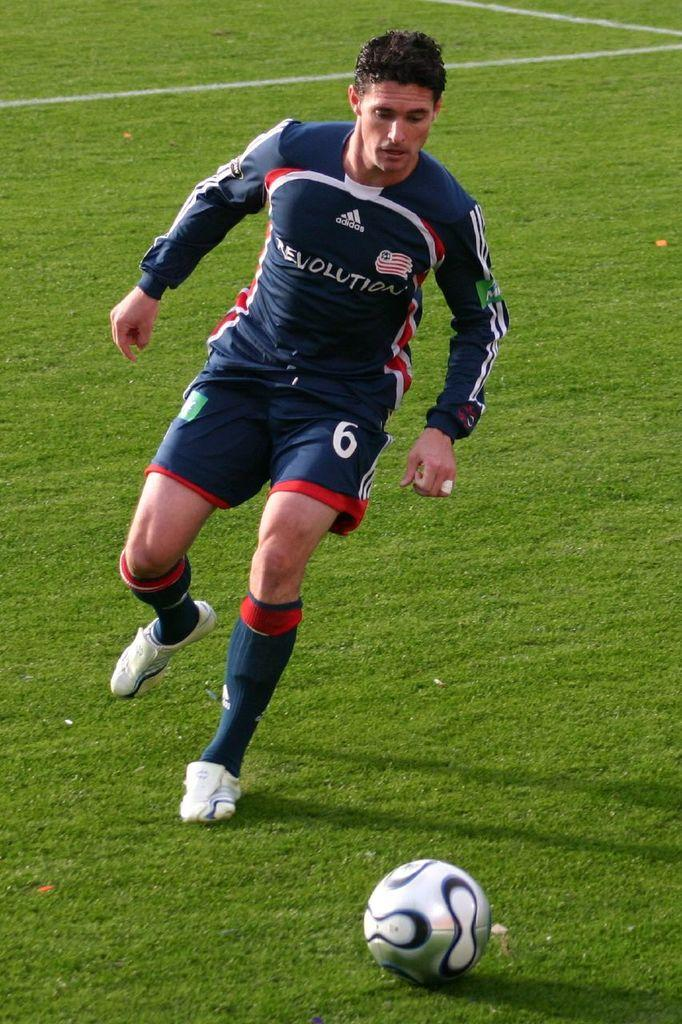Who or what is the main subject in the image? There is a person in the image. What object is in front of the person? There is a ball in front of the person. What type of surface is visible at the bottom of the image? There is grass on the surface at the bottom of the image. What word is written on the ball in the image? There is no word written on the ball in the image; it is just a plain ball. 